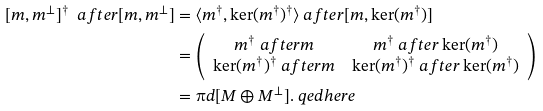Convert formula to latex. <formula><loc_0><loc_0><loc_500><loc_500>[ m , m ^ { \perp } ] ^ { \dag } \ a f t e r [ m , m ^ { \perp } ] & = \langle m ^ { \dag } , \ker ( m ^ { \dag } ) ^ { \dag } \rangle \ a f t e r [ m , \ker ( m ^ { \dag } ) ] \\ & = \left ( \begin{array} { c c } m ^ { \dag } \ a f t e r m & m ^ { \dag } \ a f t e r \ker ( m ^ { \dag } ) \\ \ker ( m ^ { \dag } ) ^ { \dag } \ a f t e r m & \ker ( m ^ { \dag } ) ^ { \dag } \ a f t e r \ker ( m ^ { \dag } ) \end{array} \right ) \\ & = \i d [ M \oplus M ^ { \perp } ] . \ q e d h e r e</formula> 